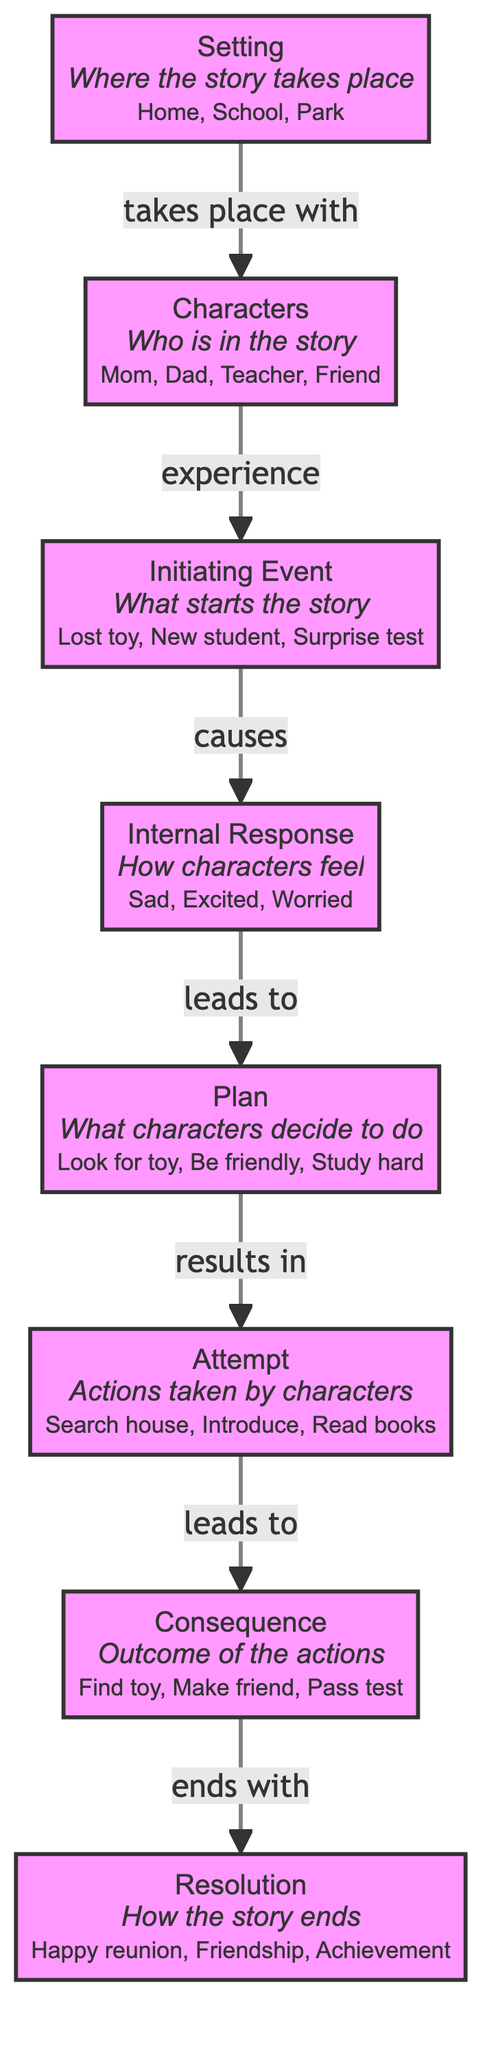what is the initiating event in the diagram? The initiating event in the diagram is represented by the node labeled "Initiating Event," which includes elements like "Lost toy" and "New student." This node defines the trigger that starts the story.
Answer: Initiating Event how many components are there in the story grammar? The diagram includes seven distinct components: Setting, Characters, Initiating Event, Internal Response, Plan, Attempt, Consequence, and Resolution. Therefore, there are a total of 7 components.
Answer: 7 which two components are directly connected by an edge that indicates cause? The edge marked "causes" connects the "Initiating Event" node to the "Internal Response" node, indicating that the initiating event leads to the characters' internal feelings or responses.
Answer: Initiating Event and Internal Response what action does the plan lead to? The "Plan" node leads to the "Attempt" node, as indicated by the connecting edge. This means whatever plan is devised will result in a subsequent attempt to act on that plan.
Answer: Attempt which component represents how the story ends? The component that represents how the story ends is labeled "Resolution." This node encapsulates the final outcome or conclusion of the narrative.
Answer: Resolution which components are experience and lead to feelings? The "Initiating Event" node is said to experience the characters, while the "Internal Response" node leads to the characters' feelings. Thus, these two components serve this function in the diagram.
Answer: Initiating Event and Internal Response what does the consequence node depict? The "Consequence" node depicts the outcomes of the characters' actions taken in response to the plan. It includes results such as "Find toy" and "Make friend," summarizing the effects of their attempts.
Answer: Outcome of the actions which nodes are connected by the edge labeled "ends with"? The edge labeled "ends with" connects the "Consequence" node to the "Resolution" node. This signifies that the outcome of the actions leads directly to how the story concludes.
Answer: Consequence and Resolution 